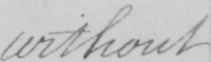What does this handwritten line say? without 